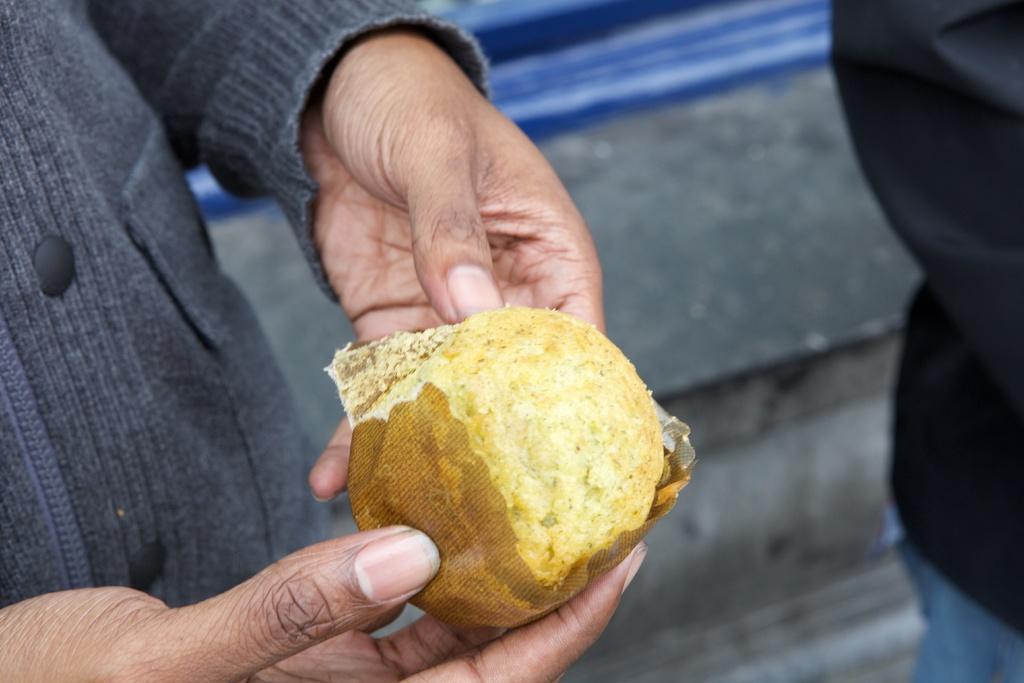In one or two sentences, can you explain what this image depicts? In this image a person is holding some food item with the hands and the background of the person is blur. 